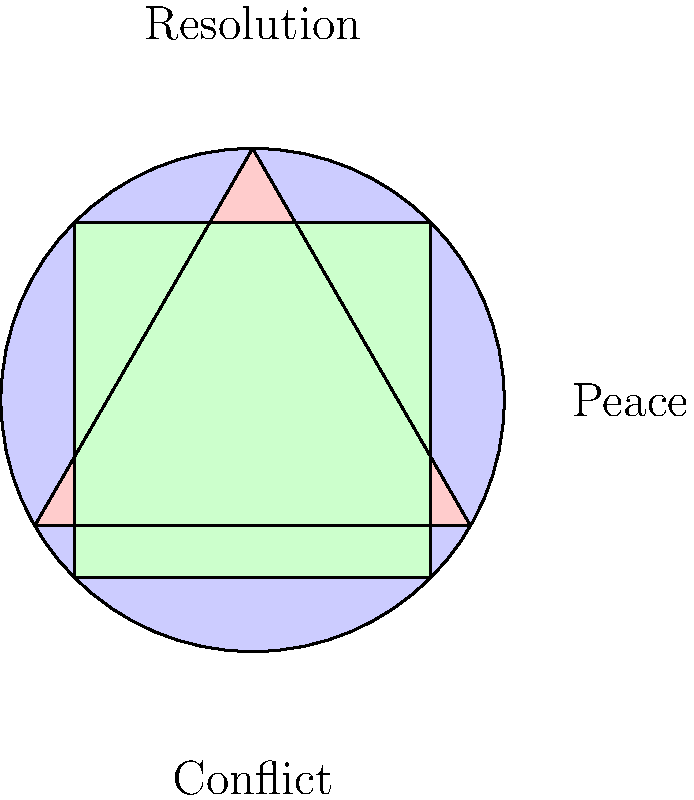In the abstract poster design shown above, which shape most effectively represents the concept of peace, and why might this be particularly impactful for someone who has experienced war firsthand? 1. Analyze the shapes: The poster contains three basic shapes - a circle, a triangle, and a square.

2. Consider the symbolism:
   - Circle: Often represents unity, wholeness, and harmony.
   - Triangle: Can symbolize conflict or tension due to its sharp angles.
   - Square: Typically associated with stability and balance.

3. Examine the labels:
   - "Conflict" is placed below, suggesting a foundation or starting point.
   - "Resolution" is above, implying a goal or destination.
   - "Peace" is to the right, possibly indicating the outcome.

4. Relate to peace symbolism: The circle is most commonly associated with peace due to its lack of sharp edges and its representation of unity.

5. Consider the impact on someone who has experienced war:
   - The smooth, continuous nature of the circle contrasts sharply with the jagged, unpredictable nature of war.
   - The circle's wholeness can represent a desire for completeness and healing after the fragmentation of war.
   - Its simplicity can be comforting amidst the complexity of conflict.

6. Reflect on artistic expression: For someone using art to advocate for peace, the circle's universal symbolism makes it an effective and accessible choice for communicating the concept of peace across cultures.
Answer: The circle, representing unity and harmony, is most effective for symbolizing peace, especially resonating with war survivors due to its contrast with conflict's chaos. 